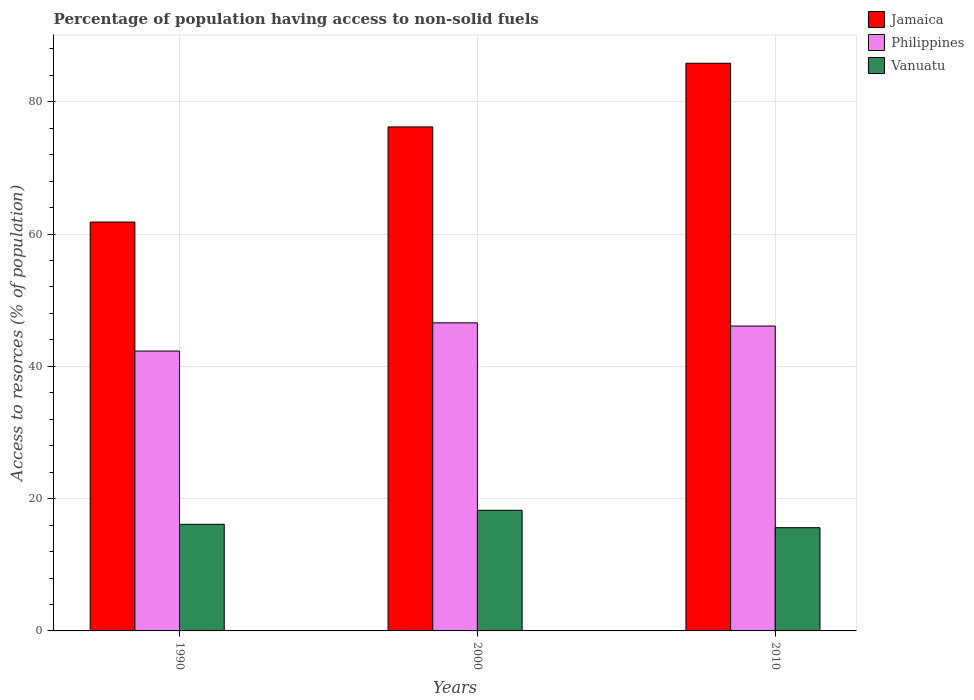How many different coloured bars are there?
Provide a succinct answer. 3. What is the percentage of population having access to non-solid fuels in Philippines in 2000?
Give a very brief answer. 46.58. Across all years, what is the maximum percentage of population having access to non-solid fuels in Philippines?
Ensure brevity in your answer.  46.58. Across all years, what is the minimum percentage of population having access to non-solid fuels in Philippines?
Your response must be concise. 42.3. In which year was the percentage of population having access to non-solid fuels in Philippines minimum?
Provide a succinct answer. 1990. What is the total percentage of population having access to non-solid fuels in Vanuatu in the graph?
Make the answer very short. 49.96. What is the difference between the percentage of population having access to non-solid fuels in Philippines in 1990 and that in 2010?
Keep it short and to the point. -3.78. What is the difference between the percentage of population having access to non-solid fuels in Jamaica in 2000 and the percentage of population having access to non-solid fuels in Philippines in 2010?
Offer a very short reply. 30.1. What is the average percentage of population having access to non-solid fuels in Jamaica per year?
Your response must be concise. 74.61. In the year 2000, what is the difference between the percentage of population having access to non-solid fuels in Jamaica and percentage of population having access to non-solid fuels in Vanuatu?
Keep it short and to the point. 57.95. In how many years, is the percentage of population having access to non-solid fuels in Jamaica greater than 4 %?
Give a very brief answer. 3. What is the ratio of the percentage of population having access to non-solid fuels in Vanuatu in 1990 to that in 2000?
Your answer should be very brief. 0.88. Is the percentage of population having access to non-solid fuels in Philippines in 1990 less than that in 2000?
Keep it short and to the point. Yes. What is the difference between the highest and the second highest percentage of population having access to non-solid fuels in Jamaica?
Your answer should be compact. 9.62. What is the difference between the highest and the lowest percentage of population having access to non-solid fuels in Philippines?
Your answer should be compact. 4.27. In how many years, is the percentage of population having access to non-solid fuels in Vanuatu greater than the average percentage of population having access to non-solid fuels in Vanuatu taken over all years?
Keep it short and to the point. 1. Is the sum of the percentage of population having access to non-solid fuels in Vanuatu in 1990 and 2000 greater than the maximum percentage of population having access to non-solid fuels in Jamaica across all years?
Your answer should be compact. No. What does the 2nd bar from the left in 2010 represents?
Provide a succinct answer. Philippines. What does the 3rd bar from the right in 2000 represents?
Your answer should be compact. Jamaica. Is it the case that in every year, the sum of the percentage of population having access to non-solid fuels in Philippines and percentage of population having access to non-solid fuels in Jamaica is greater than the percentage of population having access to non-solid fuels in Vanuatu?
Make the answer very short. Yes. How many bars are there?
Give a very brief answer. 9. How many years are there in the graph?
Make the answer very short. 3. What is the difference between two consecutive major ticks on the Y-axis?
Ensure brevity in your answer.  20. Does the graph contain any zero values?
Offer a very short reply. No. How many legend labels are there?
Ensure brevity in your answer.  3. How are the legend labels stacked?
Your response must be concise. Vertical. What is the title of the graph?
Provide a succinct answer. Percentage of population having access to non-solid fuels. What is the label or title of the X-axis?
Your answer should be very brief. Years. What is the label or title of the Y-axis?
Provide a succinct answer. Access to resorces (% of population). What is the Access to resorces (% of population) of Jamaica in 1990?
Your answer should be very brief. 61.81. What is the Access to resorces (% of population) of Philippines in 1990?
Provide a succinct answer. 42.3. What is the Access to resorces (% of population) in Vanuatu in 1990?
Provide a short and direct response. 16.12. What is the Access to resorces (% of population) of Jamaica in 2000?
Ensure brevity in your answer.  76.19. What is the Access to resorces (% of population) in Philippines in 2000?
Give a very brief answer. 46.58. What is the Access to resorces (% of population) in Vanuatu in 2000?
Make the answer very short. 18.24. What is the Access to resorces (% of population) of Jamaica in 2010?
Your response must be concise. 85.82. What is the Access to resorces (% of population) of Philippines in 2010?
Provide a short and direct response. 46.09. What is the Access to resorces (% of population) of Vanuatu in 2010?
Keep it short and to the point. 15.6. Across all years, what is the maximum Access to resorces (% of population) of Jamaica?
Make the answer very short. 85.82. Across all years, what is the maximum Access to resorces (% of population) of Philippines?
Ensure brevity in your answer.  46.58. Across all years, what is the maximum Access to resorces (% of population) in Vanuatu?
Your answer should be very brief. 18.24. Across all years, what is the minimum Access to resorces (% of population) in Jamaica?
Offer a terse response. 61.81. Across all years, what is the minimum Access to resorces (% of population) of Philippines?
Your answer should be very brief. 42.3. Across all years, what is the minimum Access to resorces (% of population) of Vanuatu?
Your answer should be very brief. 15.6. What is the total Access to resorces (% of population) in Jamaica in the graph?
Your answer should be compact. 223.82. What is the total Access to resorces (% of population) of Philippines in the graph?
Offer a very short reply. 134.97. What is the total Access to resorces (% of population) of Vanuatu in the graph?
Ensure brevity in your answer.  49.96. What is the difference between the Access to resorces (% of population) of Jamaica in 1990 and that in 2000?
Ensure brevity in your answer.  -14.38. What is the difference between the Access to resorces (% of population) of Philippines in 1990 and that in 2000?
Provide a succinct answer. -4.27. What is the difference between the Access to resorces (% of population) of Vanuatu in 1990 and that in 2000?
Ensure brevity in your answer.  -2.12. What is the difference between the Access to resorces (% of population) of Jamaica in 1990 and that in 2010?
Provide a short and direct response. -24.01. What is the difference between the Access to resorces (% of population) of Philippines in 1990 and that in 2010?
Offer a terse response. -3.78. What is the difference between the Access to resorces (% of population) of Vanuatu in 1990 and that in 2010?
Give a very brief answer. 0.51. What is the difference between the Access to resorces (% of population) of Jamaica in 2000 and that in 2010?
Ensure brevity in your answer.  -9.62. What is the difference between the Access to resorces (% of population) of Philippines in 2000 and that in 2010?
Keep it short and to the point. 0.49. What is the difference between the Access to resorces (% of population) in Vanuatu in 2000 and that in 2010?
Your answer should be compact. 2.63. What is the difference between the Access to resorces (% of population) in Jamaica in 1990 and the Access to resorces (% of population) in Philippines in 2000?
Give a very brief answer. 15.23. What is the difference between the Access to resorces (% of population) of Jamaica in 1990 and the Access to resorces (% of population) of Vanuatu in 2000?
Offer a very short reply. 43.57. What is the difference between the Access to resorces (% of population) of Philippines in 1990 and the Access to resorces (% of population) of Vanuatu in 2000?
Provide a succinct answer. 24.07. What is the difference between the Access to resorces (% of population) of Jamaica in 1990 and the Access to resorces (% of population) of Philippines in 2010?
Provide a succinct answer. 15.72. What is the difference between the Access to resorces (% of population) in Jamaica in 1990 and the Access to resorces (% of population) in Vanuatu in 2010?
Your response must be concise. 46.21. What is the difference between the Access to resorces (% of population) in Philippines in 1990 and the Access to resorces (% of population) in Vanuatu in 2010?
Give a very brief answer. 26.7. What is the difference between the Access to resorces (% of population) in Jamaica in 2000 and the Access to resorces (% of population) in Philippines in 2010?
Keep it short and to the point. 30.1. What is the difference between the Access to resorces (% of population) of Jamaica in 2000 and the Access to resorces (% of population) of Vanuatu in 2010?
Provide a short and direct response. 60.59. What is the difference between the Access to resorces (% of population) in Philippines in 2000 and the Access to resorces (% of population) in Vanuatu in 2010?
Your answer should be compact. 30.97. What is the average Access to resorces (% of population) in Jamaica per year?
Your answer should be compact. 74.61. What is the average Access to resorces (% of population) in Philippines per year?
Your answer should be very brief. 44.99. What is the average Access to resorces (% of population) in Vanuatu per year?
Offer a very short reply. 16.65. In the year 1990, what is the difference between the Access to resorces (% of population) in Jamaica and Access to resorces (% of population) in Philippines?
Make the answer very short. 19.51. In the year 1990, what is the difference between the Access to resorces (% of population) in Jamaica and Access to resorces (% of population) in Vanuatu?
Make the answer very short. 45.69. In the year 1990, what is the difference between the Access to resorces (% of population) in Philippines and Access to resorces (% of population) in Vanuatu?
Your response must be concise. 26.19. In the year 2000, what is the difference between the Access to resorces (% of population) of Jamaica and Access to resorces (% of population) of Philippines?
Offer a very short reply. 29.62. In the year 2000, what is the difference between the Access to resorces (% of population) in Jamaica and Access to resorces (% of population) in Vanuatu?
Your answer should be compact. 57.95. In the year 2000, what is the difference between the Access to resorces (% of population) of Philippines and Access to resorces (% of population) of Vanuatu?
Provide a succinct answer. 28.34. In the year 2010, what is the difference between the Access to resorces (% of population) in Jamaica and Access to resorces (% of population) in Philippines?
Keep it short and to the point. 39.73. In the year 2010, what is the difference between the Access to resorces (% of population) in Jamaica and Access to resorces (% of population) in Vanuatu?
Give a very brief answer. 70.21. In the year 2010, what is the difference between the Access to resorces (% of population) of Philippines and Access to resorces (% of population) of Vanuatu?
Give a very brief answer. 30.49. What is the ratio of the Access to resorces (% of population) in Jamaica in 1990 to that in 2000?
Make the answer very short. 0.81. What is the ratio of the Access to resorces (% of population) in Philippines in 1990 to that in 2000?
Offer a terse response. 0.91. What is the ratio of the Access to resorces (% of population) in Vanuatu in 1990 to that in 2000?
Provide a short and direct response. 0.88. What is the ratio of the Access to resorces (% of population) in Jamaica in 1990 to that in 2010?
Offer a terse response. 0.72. What is the ratio of the Access to resorces (% of population) of Philippines in 1990 to that in 2010?
Provide a succinct answer. 0.92. What is the ratio of the Access to resorces (% of population) in Vanuatu in 1990 to that in 2010?
Offer a very short reply. 1.03. What is the ratio of the Access to resorces (% of population) of Jamaica in 2000 to that in 2010?
Provide a short and direct response. 0.89. What is the ratio of the Access to resorces (% of population) in Philippines in 2000 to that in 2010?
Make the answer very short. 1.01. What is the ratio of the Access to resorces (% of population) in Vanuatu in 2000 to that in 2010?
Provide a short and direct response. 1.17. What is the difference between the highest and the second highest Access to resorces (% of population) of Jamaica?
Keep it short and to the point. 9.62. What is the difference between the highest and the second highest Access to resorces (% of population) in Philippines?
Your answer should be very brief. 0.49. What is the difference between the highest and the second highest Access to resorces (% of population) in Vanuatu?
Provide a short and direct response. 2.12. What is the difference between the highest and the lowest Access to resorces (% of population) of Jamaica?
Your answer should be compact. 24.01. What is the difference between the highest and the lowest Access to resorces (% of population) in Philippines?
Offer a very short reply. 4.27. What is the difference between the highest and the lowest Access to resorces (% of population) in Vanuatu?
Make the answer very short. 2.63. 